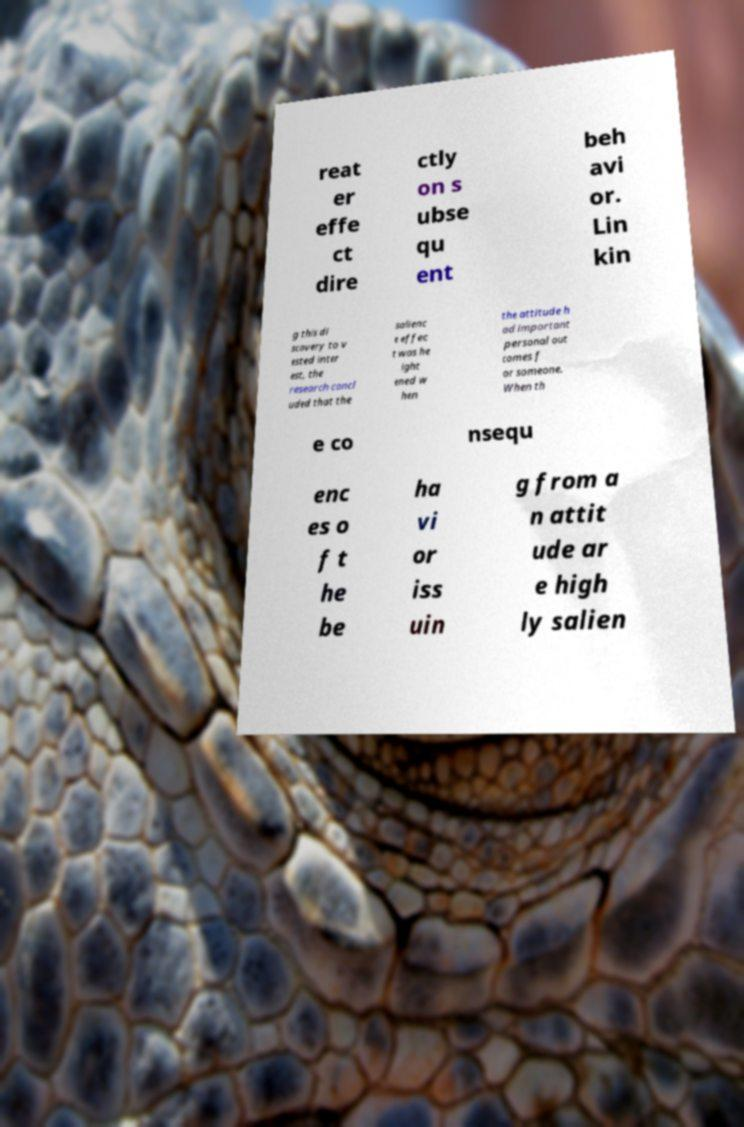There's text embedded in this image that I need extracted. Can you transcribe it verbatim? reat er effe ct dire ctly on s ubse qu ent beh avi or. Lin kin g this di scovery to v ested inter est, the research concl uded that the salienc e effec t was he ight ened w hen the attitude h ad important personal out comes f or someone. When th e co nsequ enc es o f t he be ha vi or iss uin g from a n attit ude ar e high ly salien 